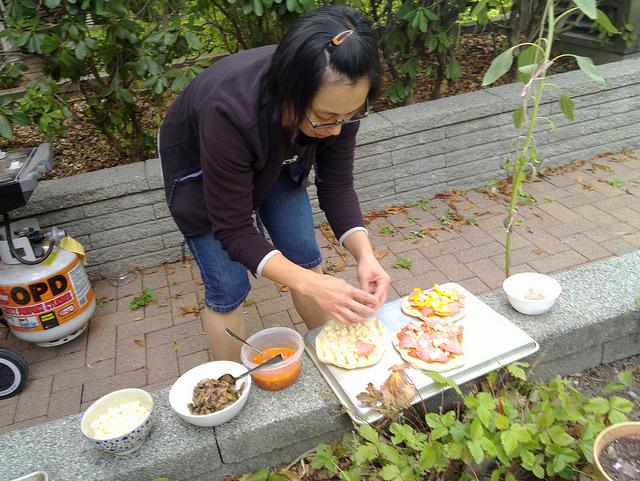Where is the woman going to put the food?
Concise answer only. Plate. Is this inside a kitchen?
Answer briefly. No. How many bowls are on the wall?
Quick response, please. 4. 